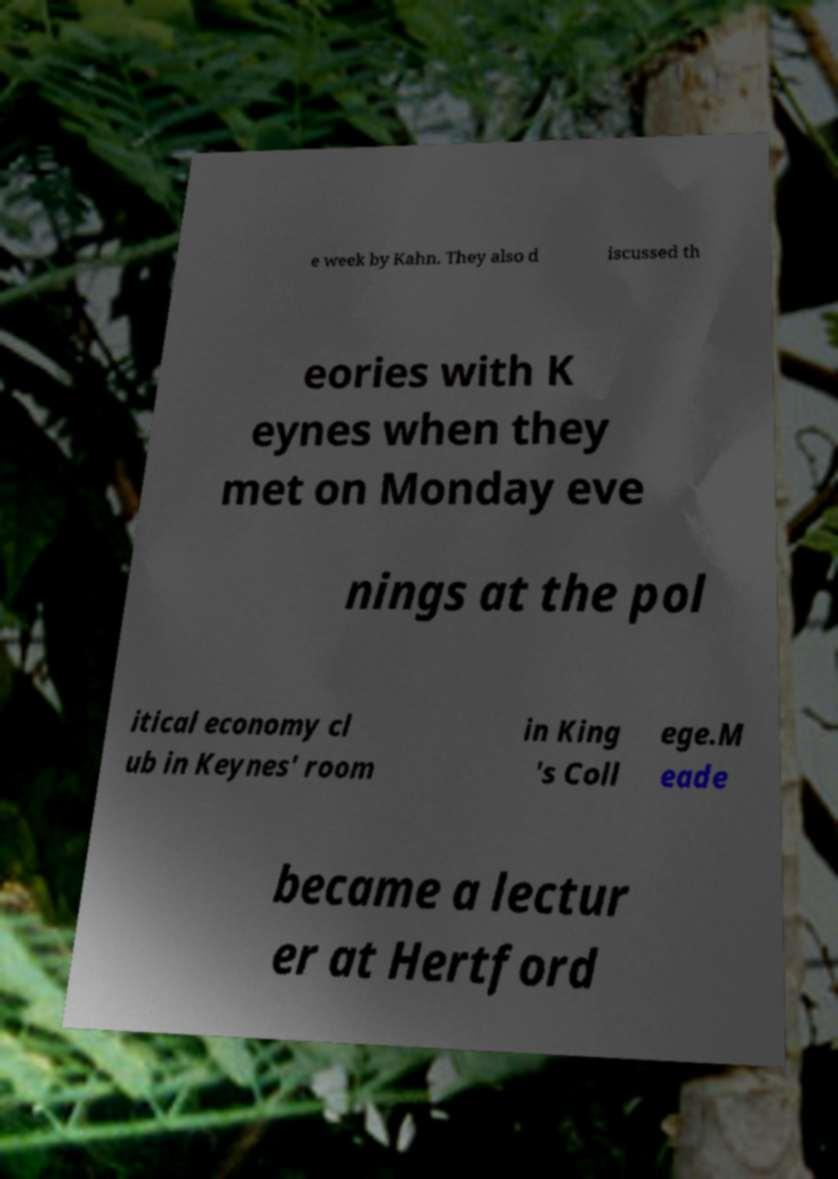Could you assist in decoding the text presented in this image and type it out clearly? e week by Kahn. They also d iscussed th eories with K eynes when they met on Monday eve nings at the pol itical economy cl ub in Keynes' room in King 's Coll ege.M eade became a lectur er at Hertford 